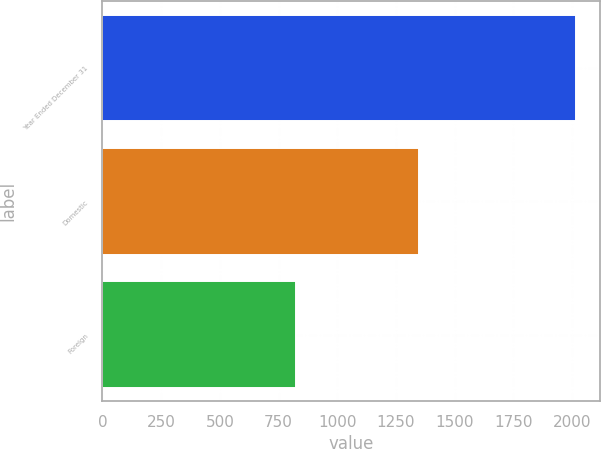Convert chart to OTSL. <chart><loc_0><loc_0><loc_500><loc_500><bar_chart><fcel>Year Ended December 31<fcel>Domestic<fcel>Foreign<nl><fcel>2017<fcel>1347.8<fcel>825.5<nl></chart> 